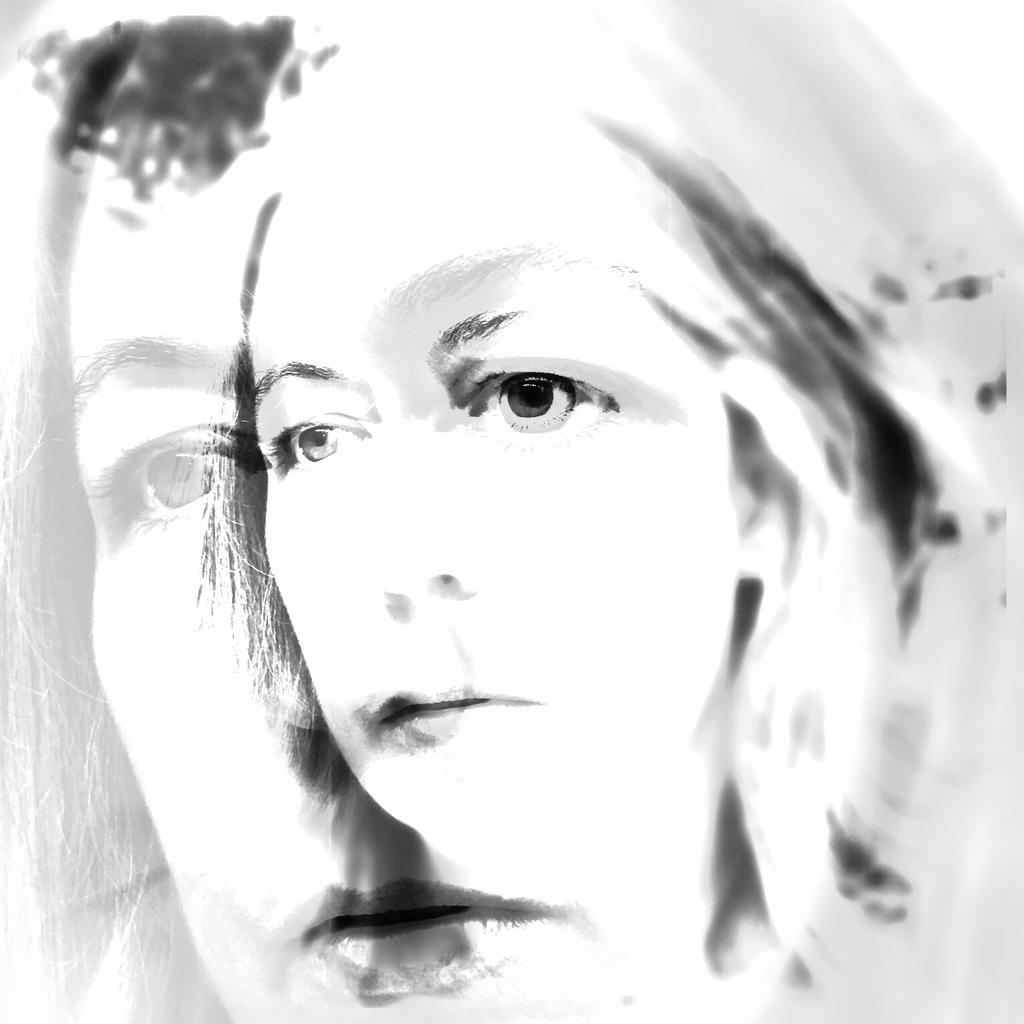What type of image is being shown? The image is an edited picture. What can be seen in the edited picture? The face of a woman is visible in the image. What is the name of the governor in the image? There is no governor present in the image; it only features the face of a woman. What type of food is being cooked in the image? There is no cooking or food preparation visible in the image. 